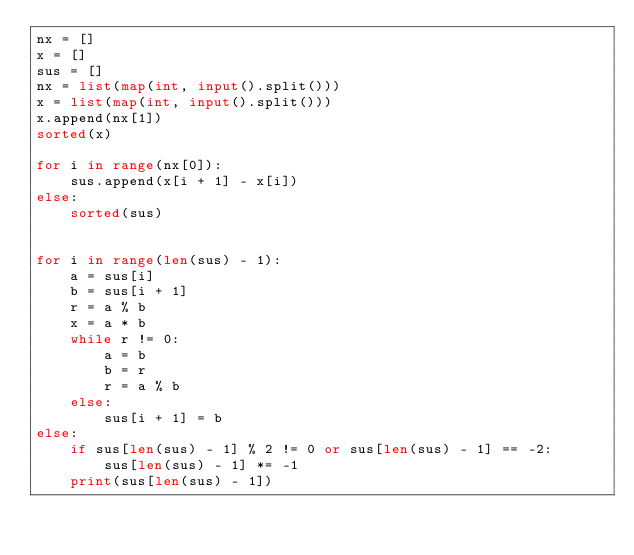Convert code to text. <code><loc_0><loc_0><loc_500><loc_500><_Python_>nx = []
x = []
sus = []
nx = list(map(int, input().split()))
x = list(map(int, input().split()))
x.append(nx[1])
sorted(x)

for i in range(nx[0]):
    sus.append(x[i + 1] - x[i])
else:
    sorted(sus)


for i in range(len(sus) - 1):
    a = sus[i]
    b = sus[i + 1]
    r = a % b
    x = a * b
    while r != 0:
        a = b
        b = r
        r = a % b
    else:
        sus[i + 1] = b
else:
    if sus[len(sus) - 1] % 2 != 0 or sus[len(sus) - 1] == -2:
        sus[len(sus) - 1] *= -1
    print(sus[len(sus) - 1])</code> 